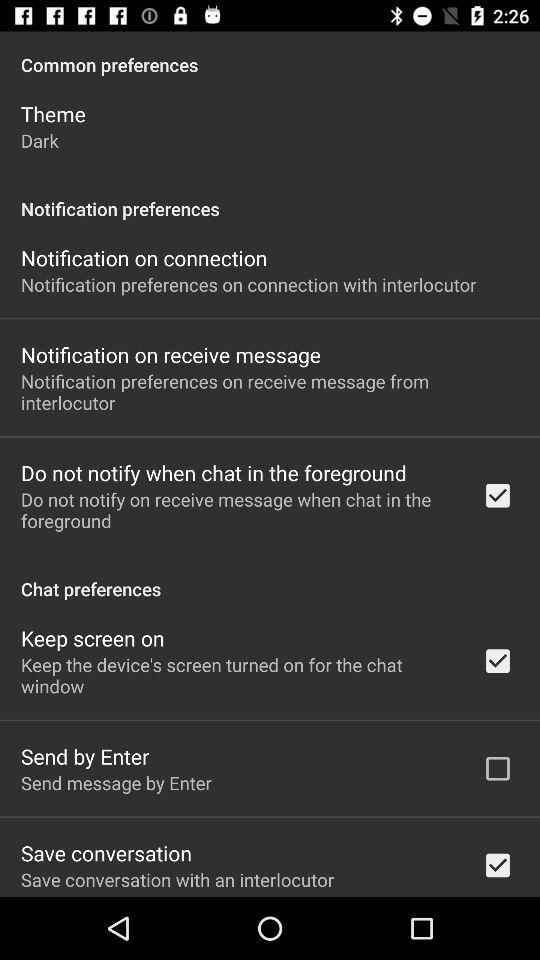What is the theme? The theme is "Dark". 